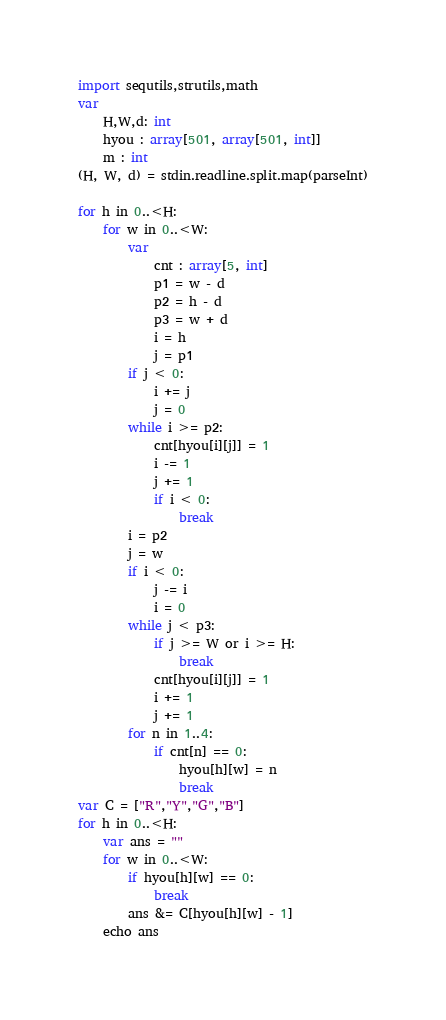Convert code to text. <code><loc_0><loc_0><loc_500><loc_500><_Nim_>import sequtils,strutils,math
var
    H,W,d: int
    hyou : array[501, array[501, int]]
    m : int
(H, W, d) = stdin.readline.split.map(parseInt)

for h in 0..<H:
    for w in 0..<W:
        var
            cnt : array[5, int]
            p1 = w - d
            p2 = h - d
            p3 = w + d
            i = h
            j = p1
        if j < 0:
            i += j
            j = 0
        while i >= p2:
            cnt[hyou[i][j]] = 1
            i -= 1
            j += 1
            if i < 0:
                break
        i = p2
        j = w
        if i < 0:
            j -= i
            i = 0
        while j < p3:
            if j >= W or i >= H:
                break
            cnt[hyou[i][j]] = 1
            i += 1
            j += 1
        for n in 1..4:
            if cnt[n] == 0:
                hyou[h][w] = n
                break
var C = ["R","Y","G","B"]
for h in 0..<H:
    var ans = ""
    for w in 0..<W:
        if hyou[h][w] == 0:
            break
        ans &= C[hyou[h][w] - 1]
    echo ans</code> 